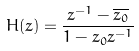<formula> <loc_0><loc_0><loc_500><loc_500>H ( z ) = \frac { z ^ { - 1 } - \overline { z _ { 0 } } } { 1 - z _ { 0 } z ^ { - 1 } }</formula> 